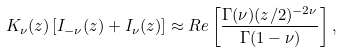Convert formula to latex. <formula><loc_0><loc_0><loc_500><loc_500>K _ { \nu } ( z ) \left [ I _ { - \nu } ( z ) + I _ { \nu } ( z ) \right ] \approx { R e } \left [ \frac { \Gamma ( \nu ) ( z / 2 ) ^ { - 2 \nu } } { \Gamma ( 1 - \nu ) } \right ] ,</formula> 